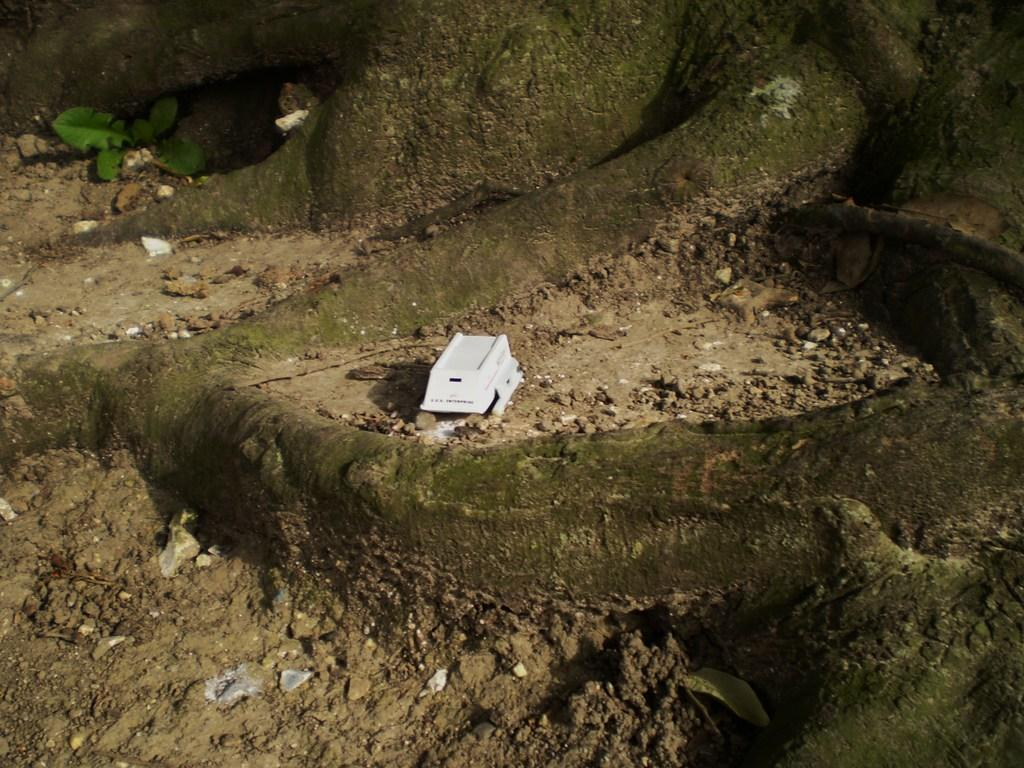Where was the image taken? The image was clicked outside. What is the white object on the ground in the image? The white object on the ground is not specified in the facts. What type of surface is visible in the image? Gravels are visible in the image. What type of vegetation is present in the image? Leaves are present in the image. What part of a tree can be seen in the image? The roots of a tree are visible in the image. How many friends are visible in the image? There are no friends visible in the image; it features a landscape with gravels, leaves, and tree roots. What type of coach is present in the image? There is no coach present in the image. 